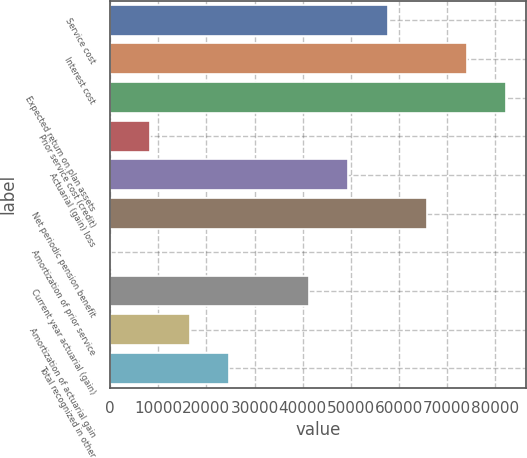Convert chart. <chart><loc_0><loc_0><loc_500><loc_500><bar_chart><fcel>Service cost<fcel>Interest cost<fcel>Expected return on plan assets<fcel>Prior service cost (credit)<fcel>Actuarial (gain) loss<fcel>Net periodic pension benefit<fcel>Amortization of prior service<fcel>Current year actuarial (gain)<fcel>Amortization of actuarial gain<fcel>Total recognized in other<nl><fcel>57624.3<fcel>74038.1<fcel>82245<fcel>8382.9<fcel>49417.4<fcel>65831.2<fcel>176<fcel>41210.5<fcel>16589.8<fcel>24796.7<nl></chart> 